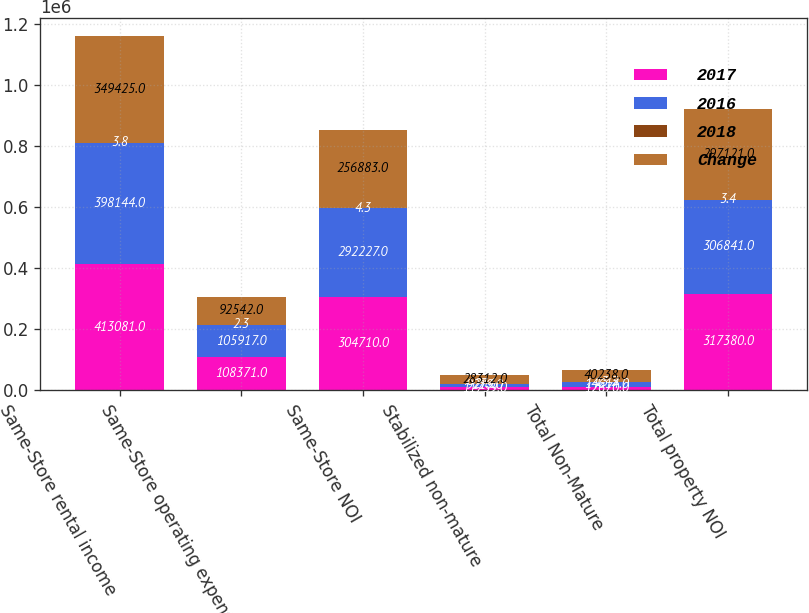<chart> <loc_0><loc_0><loc_500><loc_500><stacked_bar_chart><ecel><fcel>Same-Store rental income<fcel>Same-Store operating expense<fcel>Same-Store NOI<fcel>Stabilized non-mature<fcel>Total Non-Mature<fcel>Total property NOI<nl><fcel>2017<fcel>413081<fcel>108371<fcel>304710<fcel>11759<fcel>12670<fcel>317380<nl><fcel>2016<fcel>398144<fcel>105917<fcel>292227<fcel>9219<fcel>14614<fcel>306841<nl><fcel>2018<fcel>3.8<fcel>2.3<fcel>4.3<fcel>27.6<fcel>13.3<fcel>3.4<nl><fcel>Change<fcel>349425<fcel>92542<fcel>256883<fcel>28312<fcel>40238<fcel>297121<nl></chart> 